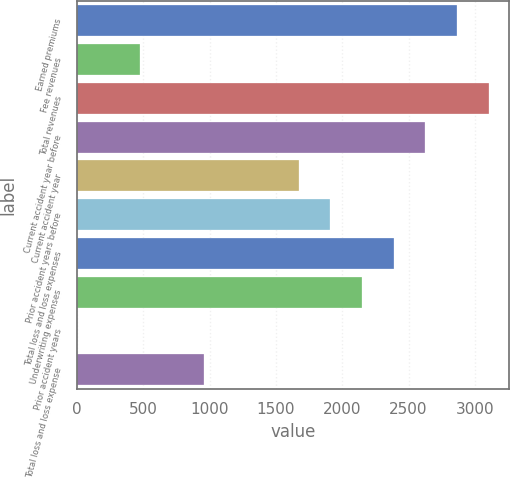<chart> <loc_0><loc_0><loc_500><loc_500><bar_chart><fcel>Earned premiums<fcel>Fee revenues<fcel>Total revenues<fcel>Current accident year before<fcel>Current accident year<fcel>Prior accident years before<fcel>Total loss and loss expenses<fcel>Underwriting expenses<fcel>Prior accident years<fcel>Total loss and loss expense<nl><fcel>2864.26<fcel>477.96<fcel>3102.89<fcel>2625.63<fcel>1671.11<fcel>1909.74<fcel>2387<fcel>2148.37<fcel>0.7<fcel>955.22<nl></chart> 